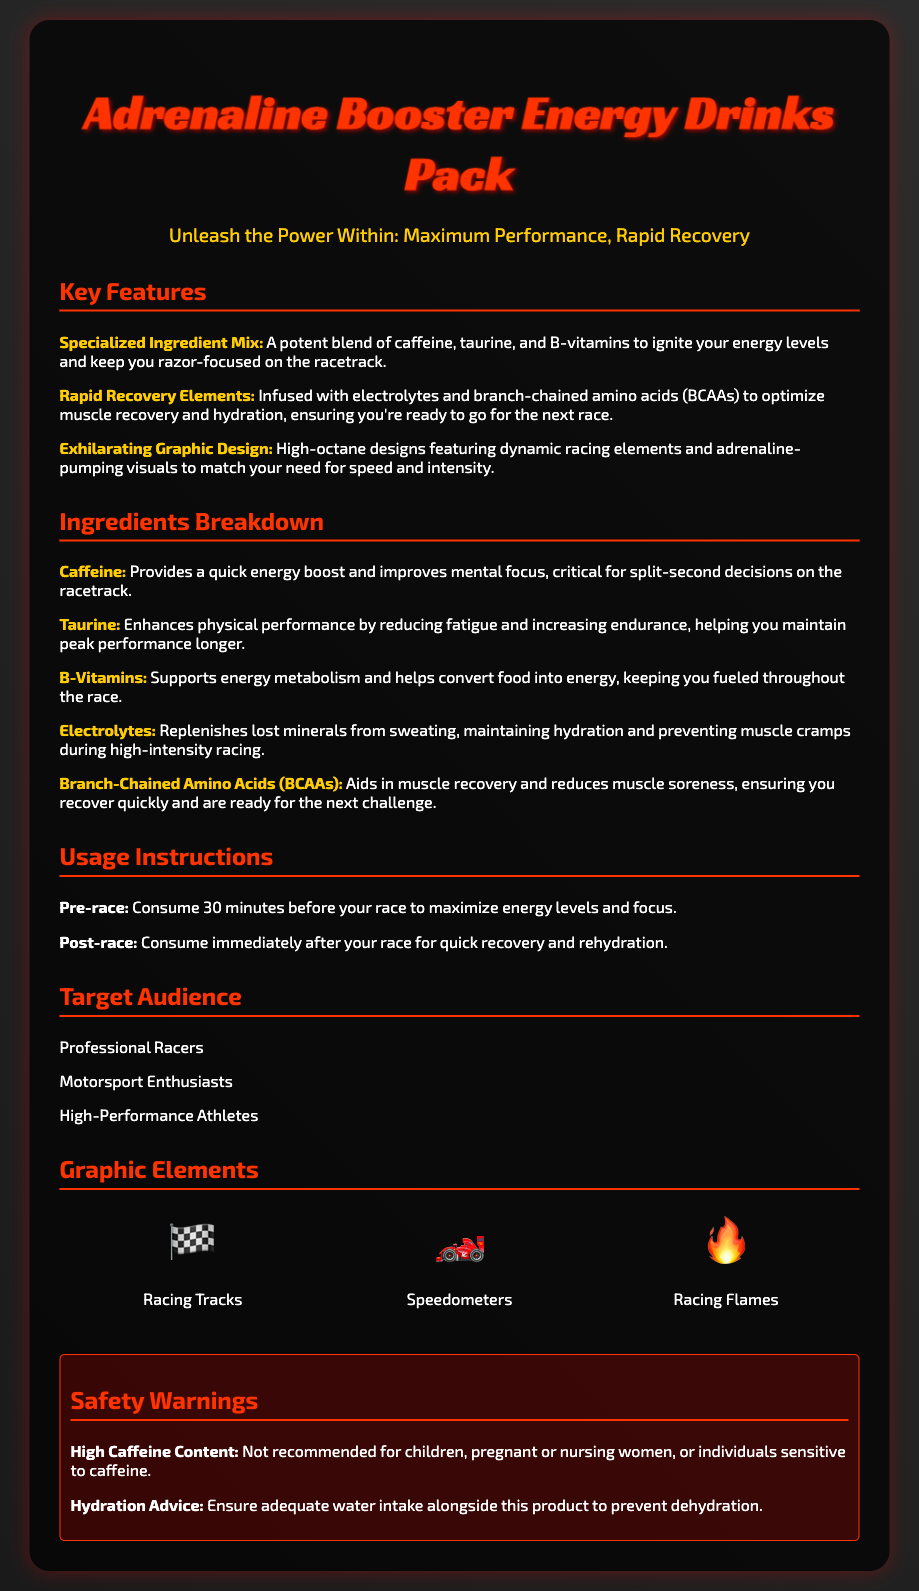what ingredients are included in the energy drink? The document lists Caffeine, Taurine, B-Vitamins, Electrolytes, and Branch-Chained Amino Acids (BCAAs) as the ingredients.
Answer: Caffeine, Taurine, B-Vitamins, Electrolytes, BCAAs what is the key feature of the product related to recovery? The key feature emphasizing recovery is the inclusion of electrolytes and BCAAs for muscle recovery and hydration.
Answer: Rapid Recovery Elements what is the target audience for this energy drink? The document specifies that professional racers, motorsport enthusiasts, and high-performance athletes are the target audience.
Answer: Professional Racers, Motorsport Enthusiasts, High-Performance Athletes how long before a race should the drink be consumed? The instructions state that the drink should be consumed 30 minutes before a race for maximum energy levels.
Answer: 30 minutes what graphic element represents speed in the design? The speedometer graphic element represents speed in the product packaging design.
Answer: Speedometers how does caffeine benefit racetrack performance? Caffeine provides a quick energy boost and improves mental focus, which is critical for split-second decisions on the racetrack.
Answer: Quick energy boost and improved mental focus what is the color scheme used in the container background? The background is styled with a linear gradient of dark shades of two colors: #1a1a1a and #2c2c2c.
Answer: Dark gradient (black shades) what should be done alongside this product to prevent dehydration? The document advises ensuring adequate water intake alongside the product to prevent dehydration.
Answer: Ensure adequate water intake 